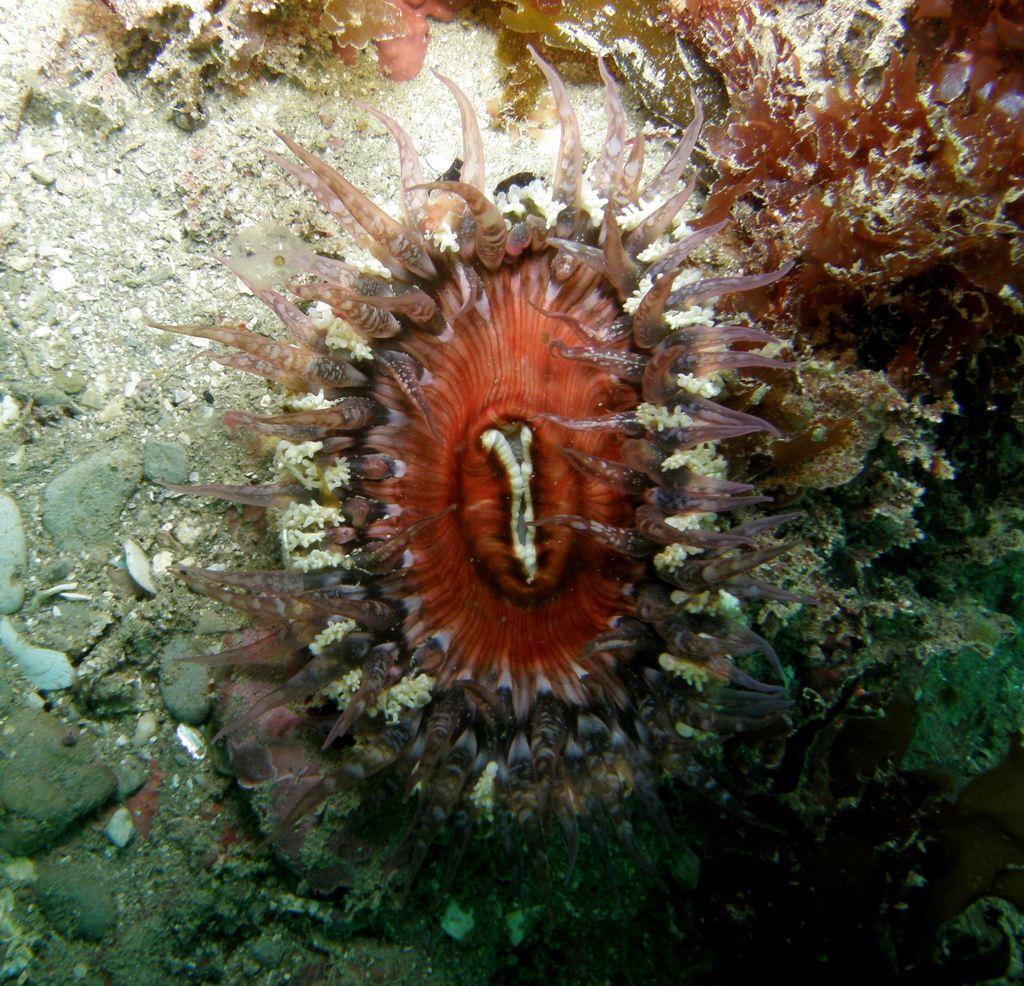Could you give a brief overview of what you see in this image? In this image in the middle we can see, there is some kind of plant and there are many rocks. 